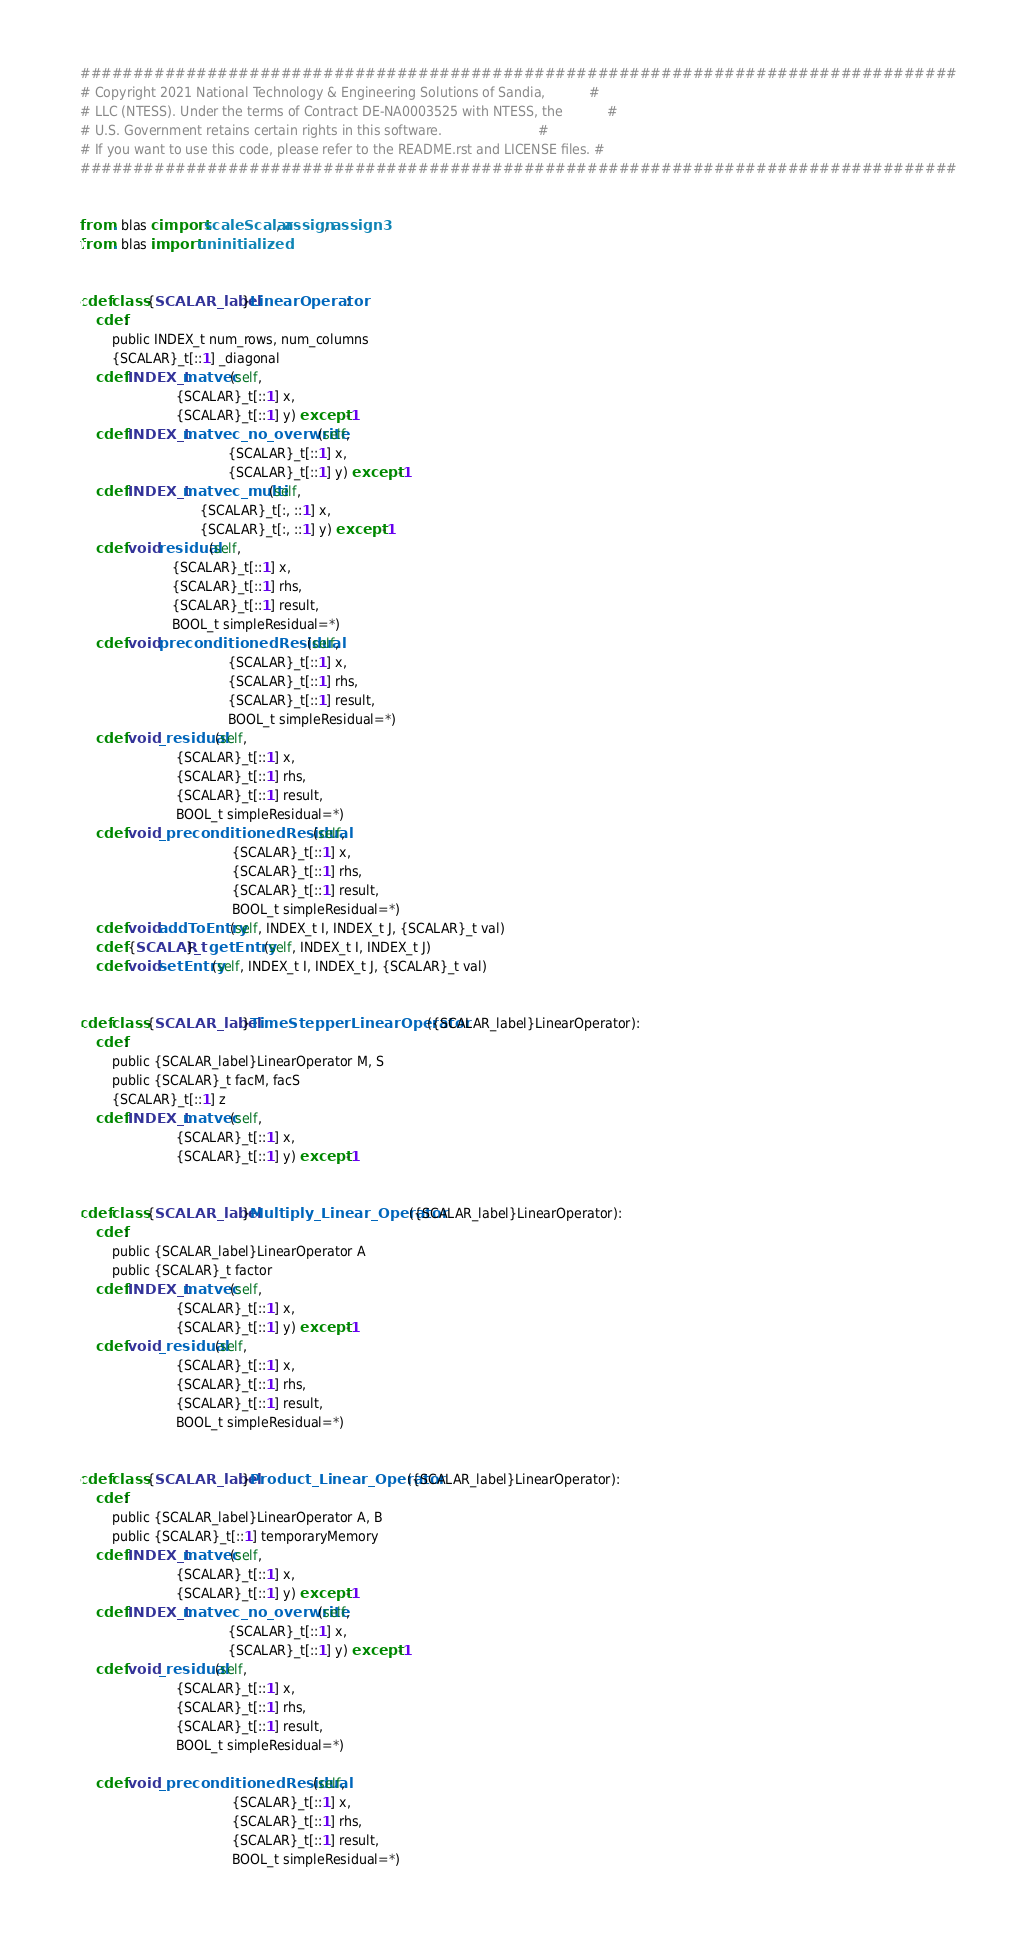<code> <loc_0><loc_0><loc_500><loc_500><_Cython_>###################################################################################
# Copyright 2021 National Technology & Engineering Solutions of Sandia,           #
# LLC (NTESS). Under the terms of Contract DE-NA0003525 with NTESS, the           #
# U.S. Government retains certain rights in this software.                        #
# If you want to use this code, please refer to the README.rst and LICENSE files. #
###################################################################################


from . blas cimport scaleScalar, assign, assign3
from . blas import uninitialized


cdef class {SCALAR_label}LinearOperator:
    cdef:
        public INDEX_t num_rows, num_columns
        {SCALAR}_t[::1] _diagonal
    cdef INDEX_t matvec(self,
                        {SCALAR}_t[::1] x,
                        {SCALAR}_t[::1] y) except -1
    cdef INDEX_t matvec_no_overwrite(self,
                                     {SCALAR}_t[::1] x,
                                     {SCALAR}_t[::1] y) except -1
    cdef INDEX_t matvec_multi(self,
                              {SCALAR}_t[:, ::1] x,
                              {SCALAR}_t[:, ::1] y) except -1
    cdef void residual(self,
                       {SCALAR}_t[::1] x,
                       {SCALAR}_t[::1] rhs,
                       {SCALAR}_t[::1] result,
                       BOOL_t simpleResidual=*)
    cdef void preconditionedResidual(self,
                                     {SCALAR}_t[::1] x,
                                     {SCALAR}_t[::1] rhs,
                                     {SCALAR}_t[::1] result,
                                     BOOL_t simpleResidual=*)
    cdef void _residual(self,
                        {SCALAR}_t[::1] x,
                        {SCALAR}_t[::1] rhs,
                        {SCALAR}_t[::1] result,
                        BOOL_t simpleResidual=*)
    cdef void _preconditionedResidual(self,
                                      {SCALAR}_t[::1] x,
                                      {SCALAR}_t[::1] rhs,
                                      {SCALAR}_t[::1] result,
                                      BOOL_t simpleResidual=*)
    cdef void addToEntry(self, INDEX_t I, INDEX_t J, {SCALAR}_t val)
    cdef {SCALAR}_t getEntry(self, INDEX_t I, INDEX_t J)
    cdef void setEntry(self, INDEX_t I, INDEX_t J, {SCALAR}_t val)


cdef class {SCALAR_label}TimeStepperLinearOperator({SCALAR_label}LinearOperator):
    cdef:
        public {SCALAR_label}LinearOperator M, S
        public {SCALAR}_t facM, facS
        {SCALAR}_t[::1] z
    cdef INDEX_t matvec(self,
                        {SCALAR}_t[::1] x,
                        {SCALAR}_t[::1] y) except -1


cdef class {SCALAR_label}Multiply_Linear_Operator({SCALAR_label}LinearOperator):
    cdef:
        public {SCALAR_label}LinearOperator A
        public {SCALAR}_t factor
    cdef INDEX_t matvec(self,
                        {SCALAR}_t[::1] x,
                        {SCALAR}_t[::1] y) except -1
    cdef void _residual(self,
                        {SCALAR}_t[::1] x,
                        {SCALAR}_t[::1] rhs,
                        {SCALAR}_t[::1] result,
                        BOOL_t simpleResidual=*)


cdef class {SCALAR_label}Product_Linear_Operator({SCALAR_label}LinearOperator):
    cdef:
        public {SCALAR_label}LinearOperator A, B
        public {SCALAR}_t[::1] temporaryMemory
    cdef INDEX_t matvec(self,
                        {SCALAR}_t[::1] x,
                        {SCALAR}_t[::1] y) except -1
    cdef INDEX_t matvec_no_overwrite(self,
                                     {SCALAR}_t[::1] x,
                                     {SCALAR}_t[::1] y) except -1
    cdef void _residual(self,
                        {SCALAR}_t[::1] x,
                        {SCALAR}_t[::1] rhs,
                        {SCALAR}_t[::1] result,
                        BOOL_t simpleResidual=*)

    cdef void _preconditionedResidual(self,
                                      {SCALAR}_t[::1] x,
                                      {SCALAR}_t[::1] rhs,
                                      {SCALAR}_t[::1] result,
                                      BOOL_t simpleResidual=*)
</code> 